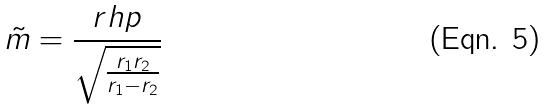<formula> <loc_0><loc_0><loc_500><loc_500>\tilde { m } = \frac { r h p } { \sqrt { \frac { r _ { 1 } r _ { 2 } } { r _ { 1 } - r _ { 2 } } } }</formula> 